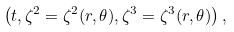<formula> <loc_0><loc_0><loc_500><loc_500>\left ( t , \zeta ^ { 2 } = \zeta ^ { 2 } ( r , \theta ) , \zeta ^ { 3 } = \zeta ^ { 3 } ( r , \theta ) \right ) ,</formula> 